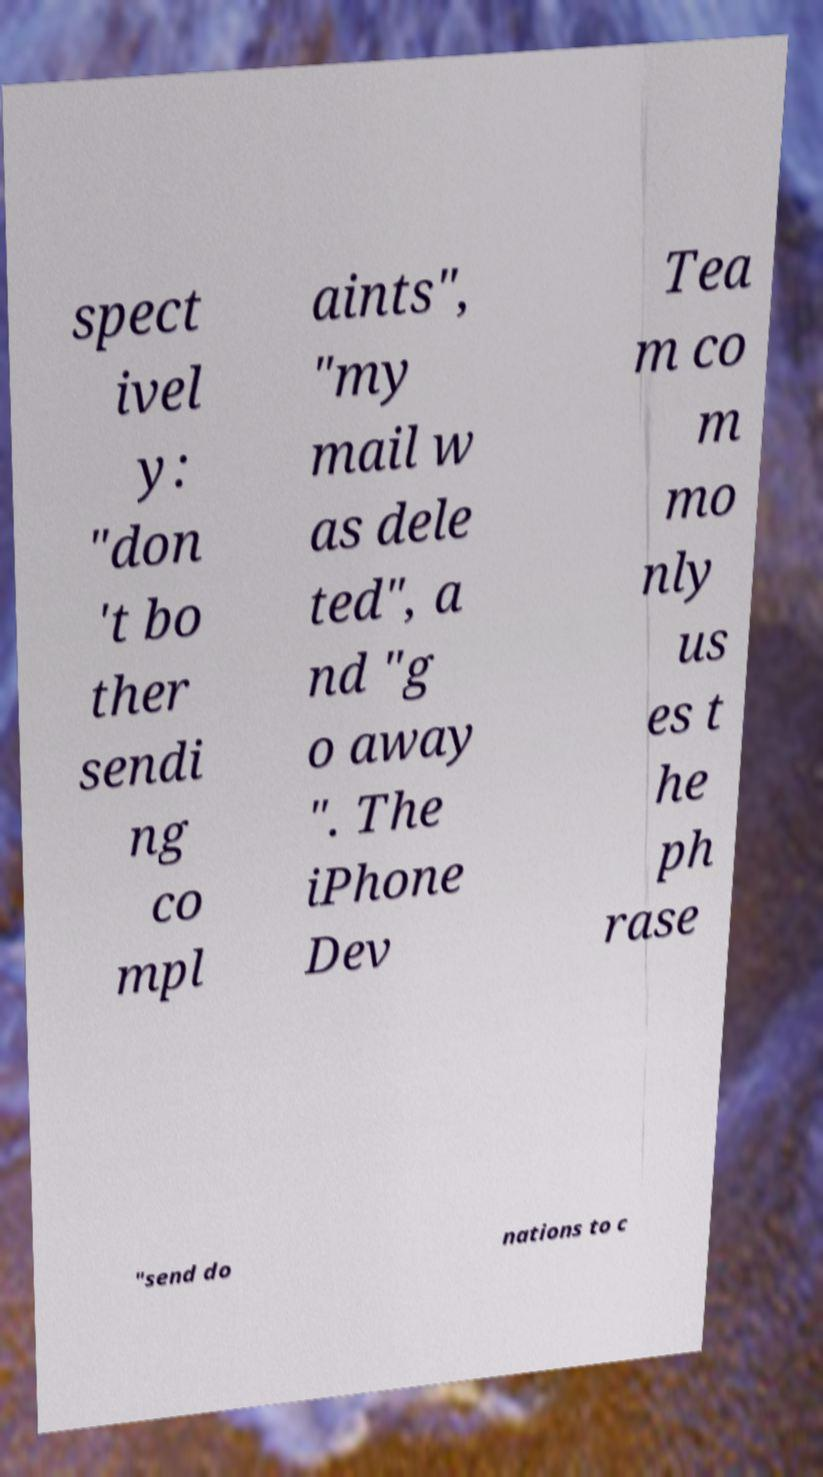I need the written content from this picture converted into text. Can you do that? spect ivel y: "don 't bo ther sendi ng co mpl aints", "my mail w as dele ted", a nd "g o away ". The iPhone Dev Tea m co m mo nly us es t he ph rase "send do nations to c 